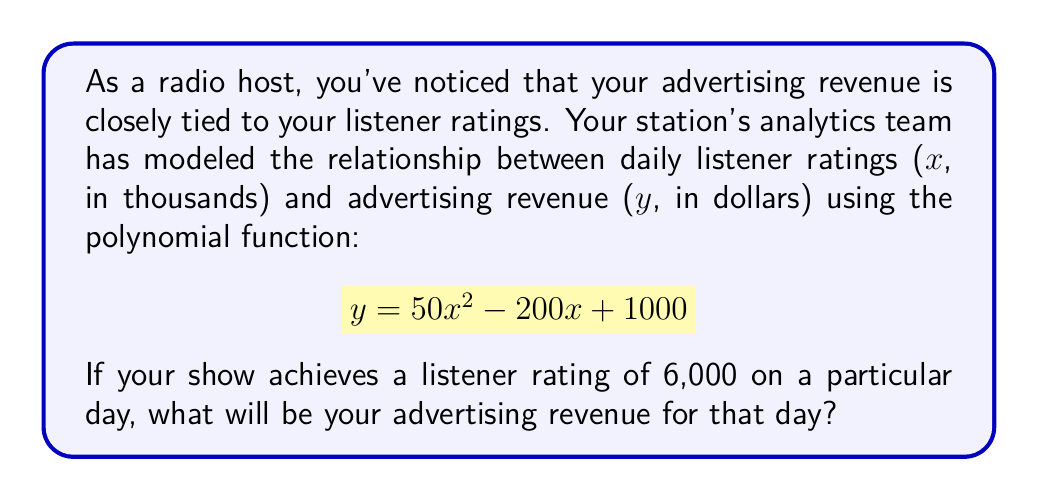Solve this math problem. To solve this problem, we need to substitute the given listener rating into the polynomial function and calculate the result. Let's break it down step-by-step:

1. The polynomial function is given as:
   $$y = 50x^2 - 200x + 1000$$

2. We're told that the listener rating is 6,000, which is 6 thousand. So, we substitute $x = 6$ into the equation:
   $$y = 50(6)^2 - 200(6) + 1000$$

3. Let's calculate each term:
   - $50(6)^2 = 50 \times 36 = 1800$
   - $-200(6) = -1200$
   - The constant term remains 1000

4. Now we can simplify:
   $$y = 1800 - 1200 + 1000$$

5. Adding these terms:
   $$y = 1600$$

Therefore, when the listener rating is 6,000, the advertising revenue will be $1,600.
Answer: $1,600 